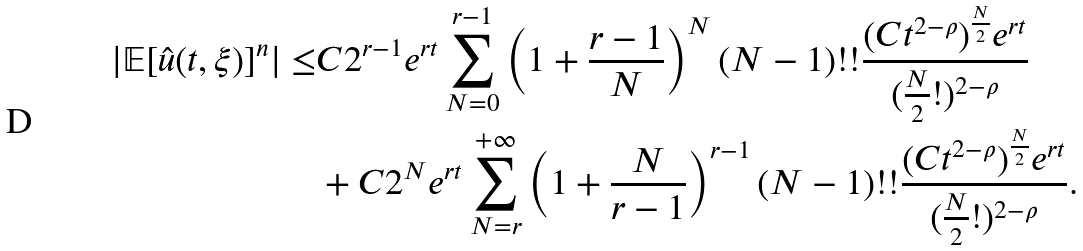Convert formula to latex. <formula><loc_0><loc_0><loc_500><loc_500>| \mathbb { E } [ \hat { u } ( t , \xi ) ] ^ { n } | \leq & C 2 ^ { r - 1 } e ^ { r t } \sum _ { N = 0 } ^ { r - 1 } \left ( 1 + \frac { r - 1 } { N } \right ) ^ { N } ( N - 1 ) ! ! \frac { ( C t ^ { 2 - \rho } ) ^ { \frac { N } { 2 } } e ^ { r t } } { ( \frac { N } { 2 } ! ) ^ { 2 - \rho } } \\ & + C 2 ^ { N } e ^ { r t } \sum _ { N = r } ^ { + \infty } \left ( 1 + \frac { N } { r - 1 } \right ) ^ { r - 1 } ( N - 1 ) ! ! \frac { ( C t ^ { 2 - \rho } ) ^ { \frac { N } { 2 } } e ^ { r t } } { ( \frac { N } { 2 } ! ) ^ { 2 - \rho } } .</formula> 